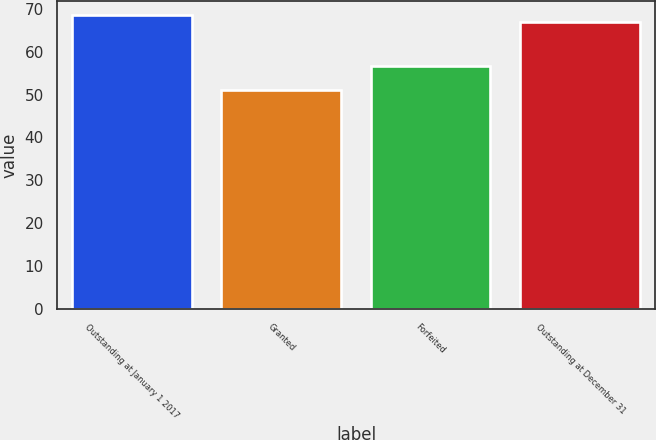Convert chart. <chart><loc_0><loc_0><loc_500><loc_500><bar_chart><fcel>Outstanding at January 1 2017<fcel>Granted<fcel>Forfeited<fcel>Outstanding at December 31<nl><fcel>68.45<fcel>51.03<fcel>56.66<fcel>66.84<nl></chart> 